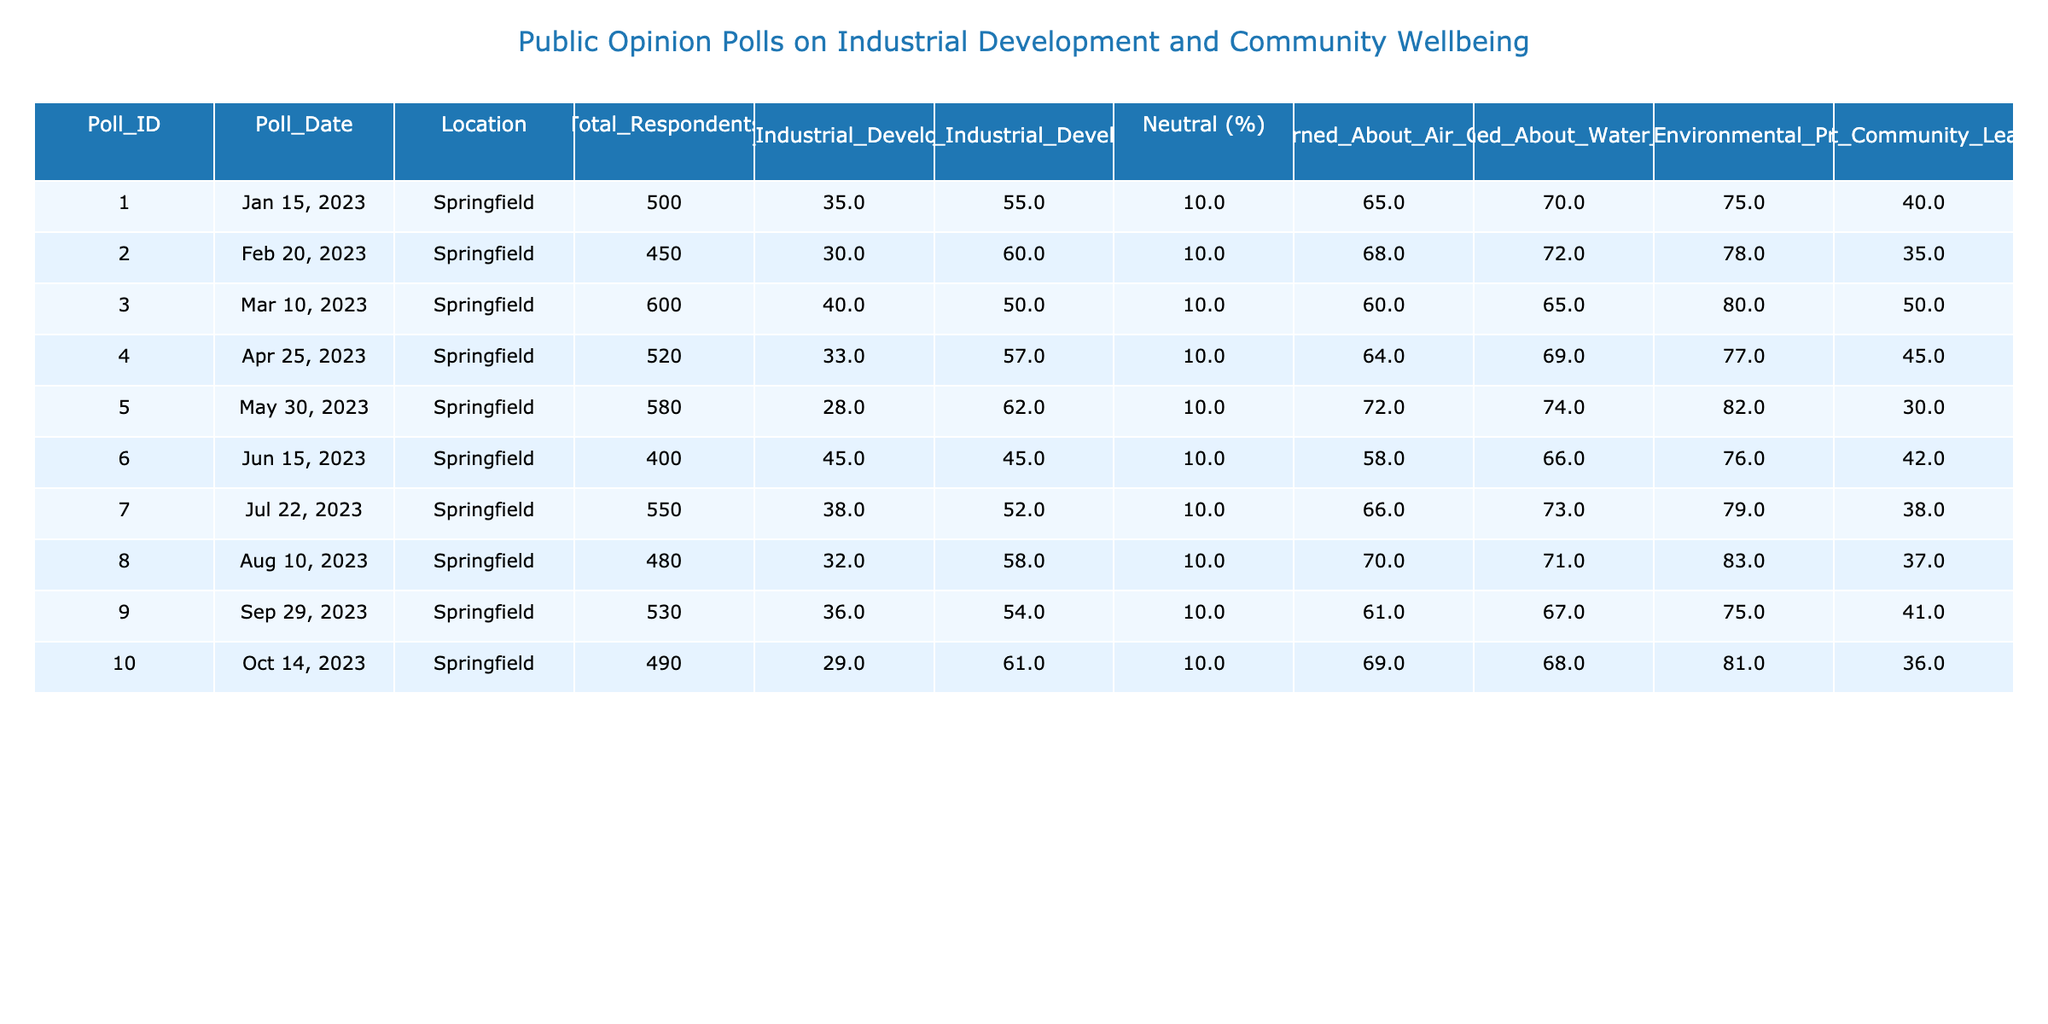What percentage of respondents opposed industrial development in the latest poll? The latest poll is Poll_ID 10 conducted on October 14, 2023. According to the table, the percentage of respondents opposing industrial development is listed as 61%.
Answer: 61% In which poll did the highest percentage of respondents favor industrial development? Looking through the "Favor_Industrial_Development (%)" column, Poll_ID 6 has the highest percentage at 45%.
Answer: 45% What is the average percentage of respondents concerned about air quality across all polls? To find the average, we sum the concerned percentages: (65 + 68 + 60 + 64 + 72 + 58 + 66 + 70 + 61 + 69) = 681. There are 10 polls, so the average is 681/10 = 68.1%.
Answer: 68.1% Did more than 50% of respondents support environmental protections in Poll 5? In Poll 5, the percentage is 82%, which is indeed more than 50%.
Answer: Yes What was the trend in opposition to industrial development from the first to the last poll? By comparing the "Oppose_Industrial_Development (%)" values: 55%, 60%, 50%, 57%, 62%, 45%, 52%, 58%, 54%, and 61%, we can see the values: 55 → 60 → 50 → 57 → 62 → 45 → 52 → 58 → 54 → 61. This shows a fluctuating trend with a general increase towards the end.
Answer: Increasing trend What was the percentage of respondents who were neutral in Poll 4? Poll 4 shows that the percentage of respondents who were neutral is 10%.
Answer: 10% Which poll had the highest percentage of trust in community leaders, and what was that percentage? Reviewing the "Trust_Community_Leaders (%)" column, Poll 3 has the highest percentage at 50%.
Answer: 50% Calculate the median percentage of respondents who were concerned about water quality. The concerned percentages are: 70, 72, 65, 69, 74, 66, 73, 71, 67, and 68. First, we sort these percentages: 65, 66, 67, 68, 69, 70, 71, 72, 73, 74. The median, being the average of the 5th and 6th values (69 and 70), is (69 + 70) / 2 = 69.5%.
Answer: 69.5% What is the difference in the percentage of respondents favoring industrial development between Poll 1 and Poll 2? Poll 1 has 35% and Poll 2 has 30% favoring industrial development. The difference is 35% - 30% = 5%.
Answer: 5% Was there a poll where less than 30% favored industrial development? The lowest percentage favoring industrial development is in Poll 5, which is 28%, confirming that there was a poll where less than 30% favored it.
Answer: Yes 